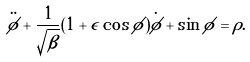<formula> <loc_0><loc_0><loc_500><loc_500>\ddot { \phi } + \frac { 1 } { \sqrt { \beta } } ( 1 + \epsilon \cos \phi ) \dot { \phi } + \sin \phi = \rho .</formula> 